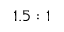<formula> <loc_0><loc_0><loc_500><loc_500>1 . 5 \colon 1</formula> 